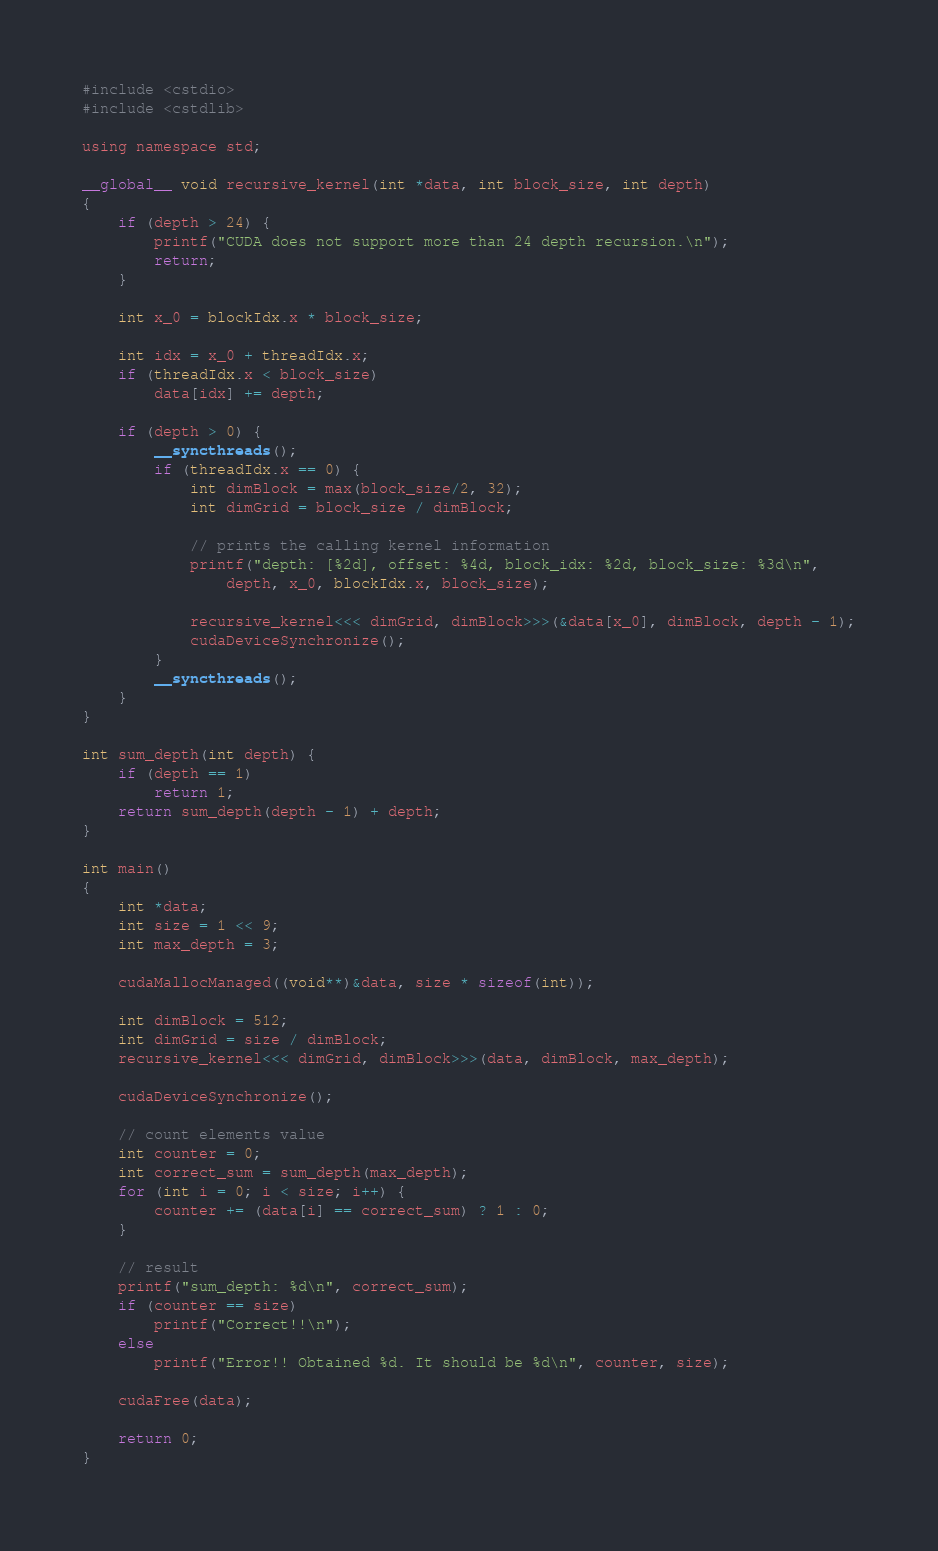<code> <loc_0><loc_0><loc_500><loc_500><_Cuda_>#include <cstdio>
#include <cstdlib>

using namespace std;

__global__ void recursive_kernel(int *data, int block_size, int depth)
{
    if (depth > 24) {
        printf("CUDA does not support more than 24 depth recursion.\n");
        return;
    }

    int x_0 = blockIdx.x * block_size;

    int idx = x_0 + threadIdx.x;
    if (threadIdx.x < block_size)
        data[idx] += depth;

    if (depth > 0) {
        __syncthreads();
        if (threadIdx.x == 0) {
            int dimBlock = max(block_size/2, 32);
            int dimGrid = block_size / dimBlock;

            // prints the calling kernel information
            printf("depth: [%2d], offset: %4d, block_idx: %2d, block_size: %3d\n", 
                depth, x_0, blockIdx.x, block_size);

            recursive_kernel<<< dimGrid, dimBlock>>>(&data[x_0], dimBlock, depth - 1);
            cudaDeviceSynchronize();
        }
        __syncthreads();
    }
}

int sum_depth(int depth) {
    if (depth == 1)
        return 1;
    return sum_depth(depth - 1) + depth;
}

int main()
{
    int *data;
    int size = 1 << 9;
    int max_depth = 3;

    cudaMallocManaged((void**)&data, size * sizeof(int));

    int dimBlock = 512;
    int dimGrid = size / dimBlock;
    recursive_kernel<<< dimGrid, dimBlock>>>(data, dimBlock, max_depth);

    cudaDeviceSynchronize();
    
    // count elements value
    int counter = 0;
    int correct_sum = sum_depth(max_depth);
    for (int i = 0; i < size; i++) {
        counter += (data[i] == correct_sum) ? 1 : 0;
    }

    // result
    printf("sum_depth: %d\n", correct_sum);
    if (counter == size)
        printf("Correct!!\n");
    else
        printf("Error!! Obtained %d. It should be %d\n", counter, size);

    cudaFree(data);

    return 0;
}

</code> 